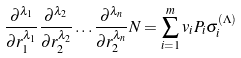<formula> <loc_0><loc_0><loc_500><loc_500>\frac { \partial ^ { \lambda _ { 1 } } } { \partial r _ { 1 } ^ { \lambda _ { 1 } } } \frac { \partial ^ { \lambda _ { 2 } } } { \partial r _ { 2 } ^ { \lambda _ { 2 } } } \dots \frac { \partial ^ { \lambda _ { n } } } { \partial r _ { 2 } ^ { \lambda _ { n } } } N = \sum _ { i = 1 } ^ { m } v _ { i } P _ { i } \sigma _ { i } ^ { ( \Lambda ) }</formula> 